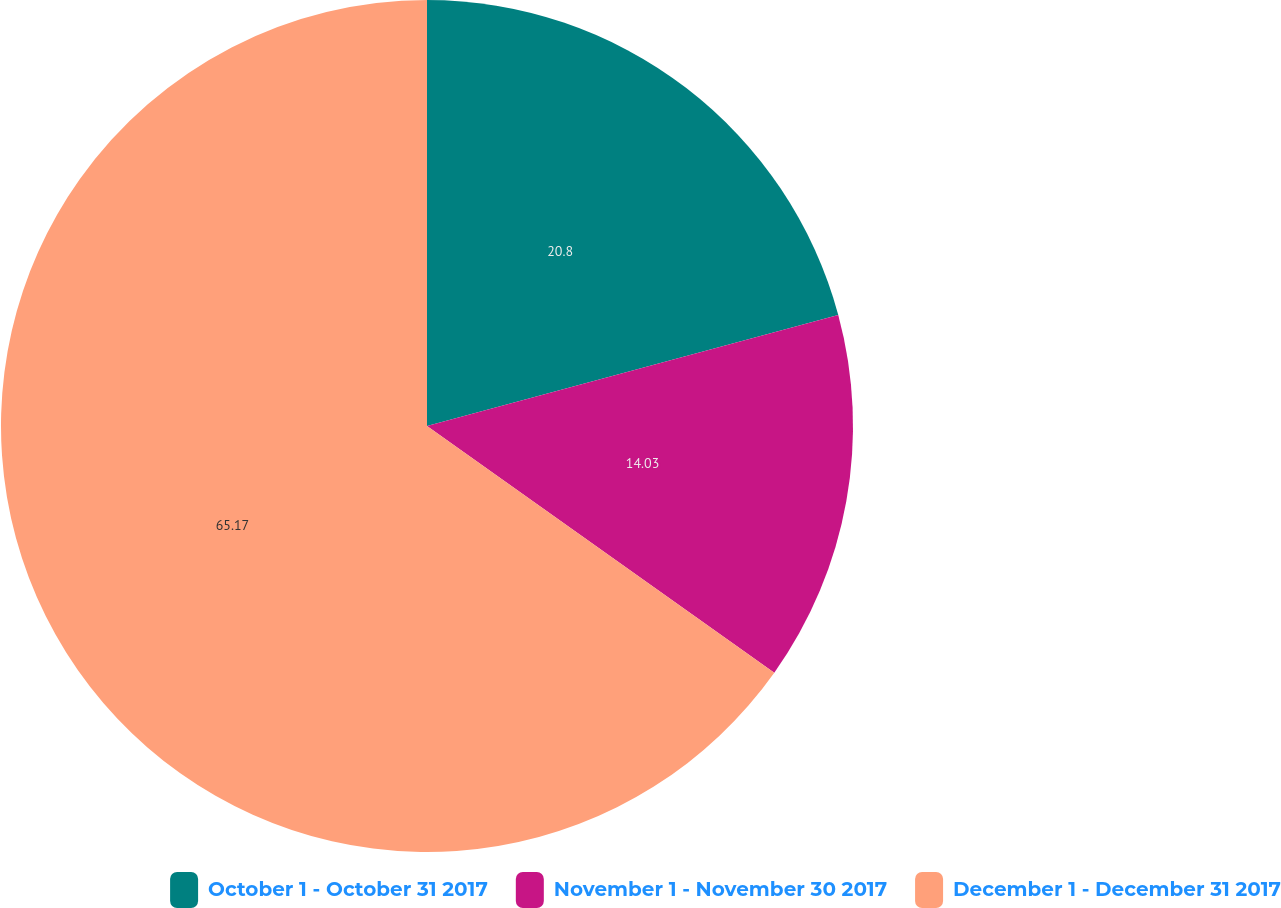Convert chart to OTSL. <chart><loc_0><loc_0><loc_500><loc_500><pie_chart><fcel>October 1 - October 31 2017<fcel>November 1 - November 30 2017<fcel>December 1 - December 31 2017<nl><fcel>20.8%<fcel>14.03%<fcel>65.17%<nl></chart> 